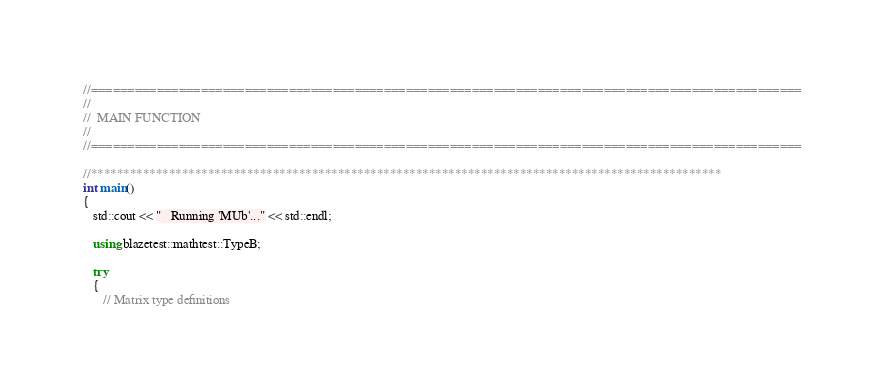<code> <loc_0><loc_0><loc_500><loc_500><_C++_>//=================================================================================================
//
//  MAIN FUNCTION
//
//=================================================================================================

//*************************************************************************************************
int main()
{
   std::cout << "   Running 'MUb'..." << std::endl;

   using blazetest::mathtest::TypeB;

   try
   {
      // Matrix type definitions</code> 